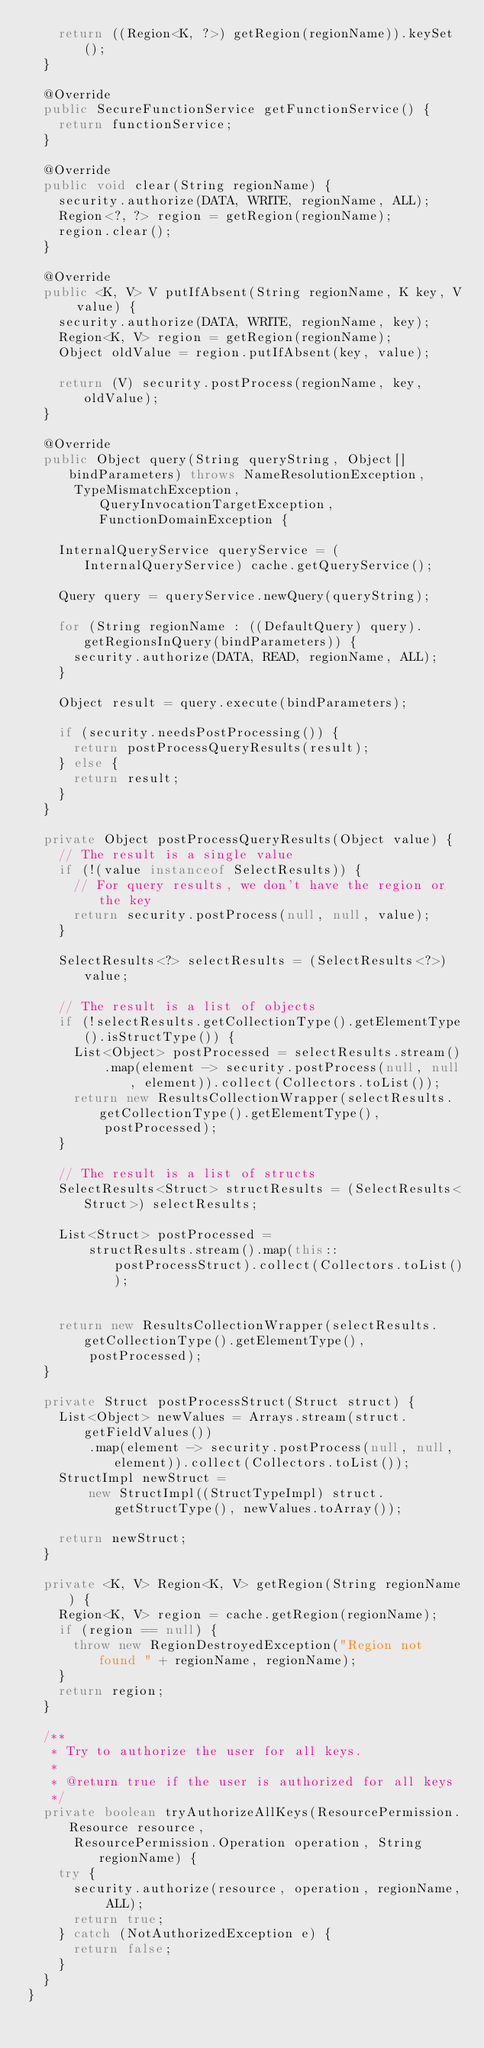<code> <loc_0><loc_0><loc_500><loc_500><_Java_>    return ((Region<K, ?>) getRegion(regionName)).keySet();
  }

  @Override
  public SecureFunctionService getFunctionService() {
    return functionService;
  }

  @Override
  public void clear(String regionName) {
    security.authorize(DATA, WRITE, regionName, ALL);
    Region<?, ?> region = getRegion(regionName);
    region.clear();
  }

  @Override
  public <K, V> V putIfAbsent(String regionName, K key, V value) {
    security.authorize(DATA, WRITE, regionName, key);
    Region<K, V> region = getRegion(regionName);
    Object oldValue = region.putIfAbsent(key, value);

    return (V) security.postProcess(regionName, key, oldValue);
  }

  @Override
  public Object query(String queryString, Object[] bindParameters) throws NameResolutionException,
      TypeMismatchException, QueryInvocationTargetException, FunctionDomainException {

    InternalQueryService queryService = (InternalQueryService) cache.getQueryService();

    Query query = queryService.newQuery(queryString);

    for (String regionName : ((DefaultQuery) query).getRegionsInQuery(bindParameters)) {
      security.authorize(DATA, READ, regionName, ALL);
    }

    Object result = query.execute(bindParameters);

    if (security.needsPostProcessing()) {
      return postProcessQueryResults(result);
    } else {
      return result;
    }
  }

  private Object postProcessQueryResults(Object value) {
    // The result is a single value
    if (!(value instanceof SelectResults)) {
      // For query results, we don't have the region or the key
      return security.postProcess(null, null, value);
    }

    SelectResults<?> selectResults = (SelectResults<?>) value;

    // The result is a list of objects
    if (!selectResults.getCollectionType().getElementType().isStructType()) {
      List<Object> postProcessed = selectResults.stream()
          .map(element -> security.postProcess(null, null, element)).collect(Collectors.toList());
      return new ResultsCollectionWrapper(selectResults.getCollectionType().getElementType(),
          postProcessed);
    }

    // The result is a list of structs
    SelectResults<Struct> structResults = (SelectResults<Struct>) selectResults;

    List<Struct> postProcessed =
        structResults.stream().map(this::postProcessStruct).collect(Collectors.toList());


    return new ResultsCollectionWrapper(selectResults.getCollectionType().getElementType(),
        postProcessed);
  }

  private Struct postProcessStruct(Struct struct) {
    List<Object> newValues = Arrays.stream(struct.getFieldValues())
        .map(element -> security.postProcess(null, null, element)).collect(Collectors.toList());
    StructImpl newStruct =
        new StructImpl((StructTypeImpl) struct.getStructType(), newValues.toArray());

    return newStruct;
  }

  private <K, V> Region<K, V> getRegion(String regionName) {
    Region<K, V> region = cache.getRegion(regionName);
    if (region == null) {
      throw new RegionDestroyedException("Region not found " + regionName, regionName);
    }
    return region;
  }

  /**
   * Try to authorize the user for all keys.
   *
   * @return true if the user is authorized for all keys
   */
  private boolean tryAuthorizeAllKeys(ResourcePermission.Resource resource,
      ResourcePermission.Operation operation, String regionName) {
    try {
      security.authorize(resource, operation, regionName, ALL);
      return true;
    } catch (NotAuthorizedException e) {
      return false;
    }
  }
}
</code> 